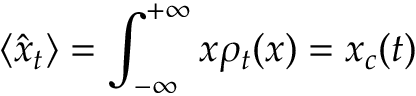Convert formula to latex. <formula><loc_0><loc_0><loc_500><loc_500>\langle \hat { x } _ { t } \rangle = \int _ { - \infty } ^ { + \infty } x \rho _ { t } ( x ) = x _ { c } ( t )</formula> 